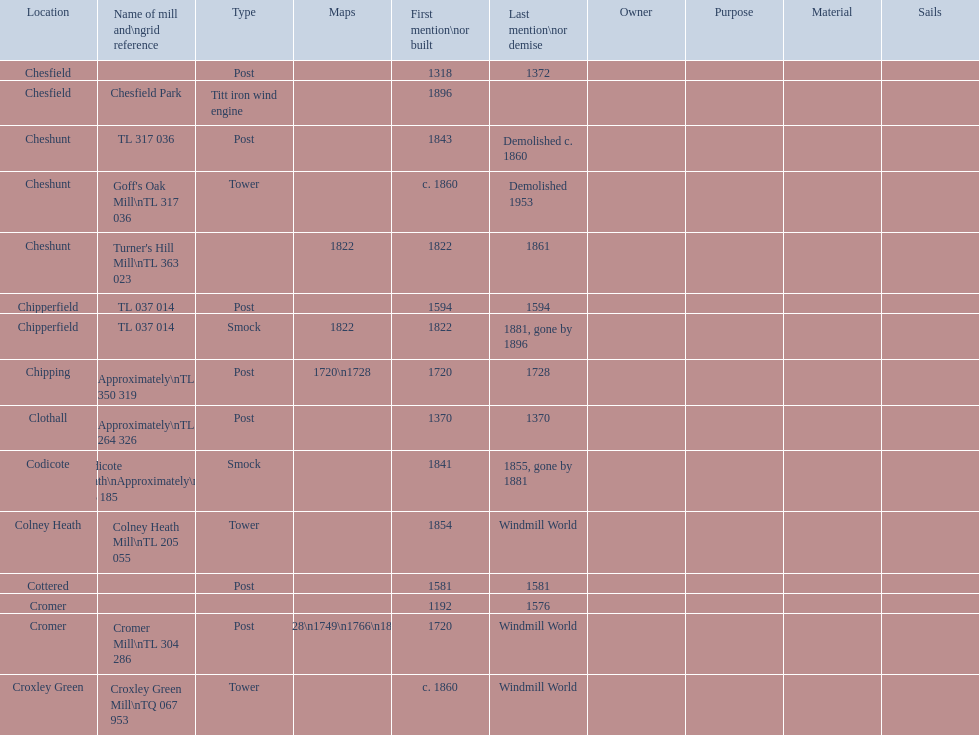Would you be able to parse every entry in this table? {'header': ['Location', 'Name of mill and\\ngrid reference', 'Type', 'Maps', 'First mention\\nor built', 'Last mention\\nor demise', 'Owner', 'Purpose', 'Material', 'Sails'], 'rows': [['Chesfield', '', 'Post', '', '1318', '1372', '', '', '', ''], ['Chesfield', 'Chesfield Park', 'Titt iron wind engine', '', '1896', '', '', '', '', ''], ['Cheshunt', 'TL 317 036', 'Post', '', '1843', 'Demolished c. 1860', '', '', '', ''], ['Cheshunt', "Goff's Oak Mill\\nTL 317 036", 'Tower', '', 'c. 1860', 'Demolished 1953', '', '', '', ''], ['Cheshunt', "Turner's Hill Mill\\nTL 363 023", '', '1822', '1822', '1861', '', '', '', ''], ['Chipperfield', 'TL 037 014', 'Post', '', '1594', '1594', '', '', '', ''], ['Chipperfield', 'TL 037 014', 'Smock', '1822', '1822', '1881, gone by 1896', '', '', '', ''], ['Chipping', 'Approximately\\nTL 350 319', 'Post', '1720\\n1728', '1720', '1728', '', '', '', ''], ['Clothall', 'Approximately\\nTL 264 326', 'Post', '', '1370', '1370', '', '', '', ''], ['Codicote', 'Codicote Heath\\nApproximately\\nTL 206 185', 'Smock', '', '1841', '1855, gone by 1881', '', '', '', ''], ['Colney Heath', 'Colney Heath Mill\\nTL 205 055', 'Tower', '', '1854', 'Windmill World', '', '', '', ''], ['Cottered', '', 'Post', '', '1581', '1581', '', '', '', ''], ['Cromer', '', '', '', '1192', '1576', '', '', '', ''], ['Cromer', 'Cromer Mill\\nTL 304 286', 'Post', '1720\\n1728\\n1749\\n1766\\n1800\\n1822', '1720', 'Windmill World', '', '', '', ''], ['Croxley Green', 'Croxley Green Mill\\nTQ 067 953', 'Tower', '', 'c. 1860', 'Windmill World', '', '', '', '']]} What is the number of mills first mentioned or built in the 1800s? 8. 